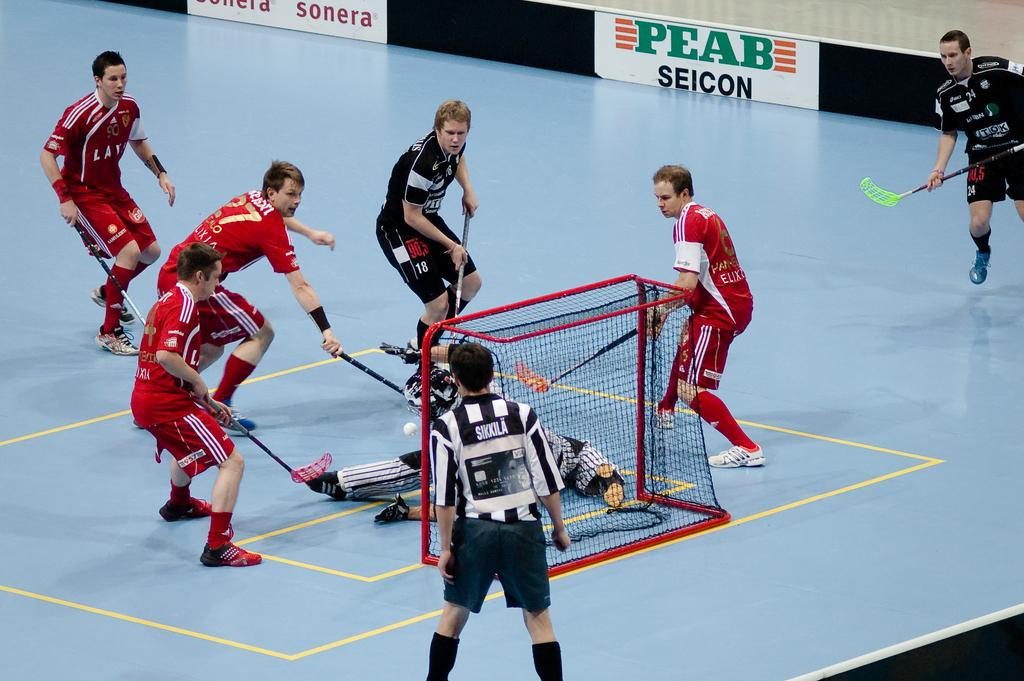Who are the subjects in the image? There are people in the image. What are the people holding in their hands? The people are holding hockey sticks. What sport are they playing? They are playing floor ball. What is the purpose of the goal post with a net in the image? The goal post with a net is used to score points in the game. What can be seen in the background of the image? There are banners in the background. What object is being used to play the game? There is a ball in the image. Can you see a snail crawling on the ball in the image? No, there is no snail present in the image. What type of sand is used to create the floor for the game in the image? The image does not show any sand, as the game is being played on a floor or court surface. 